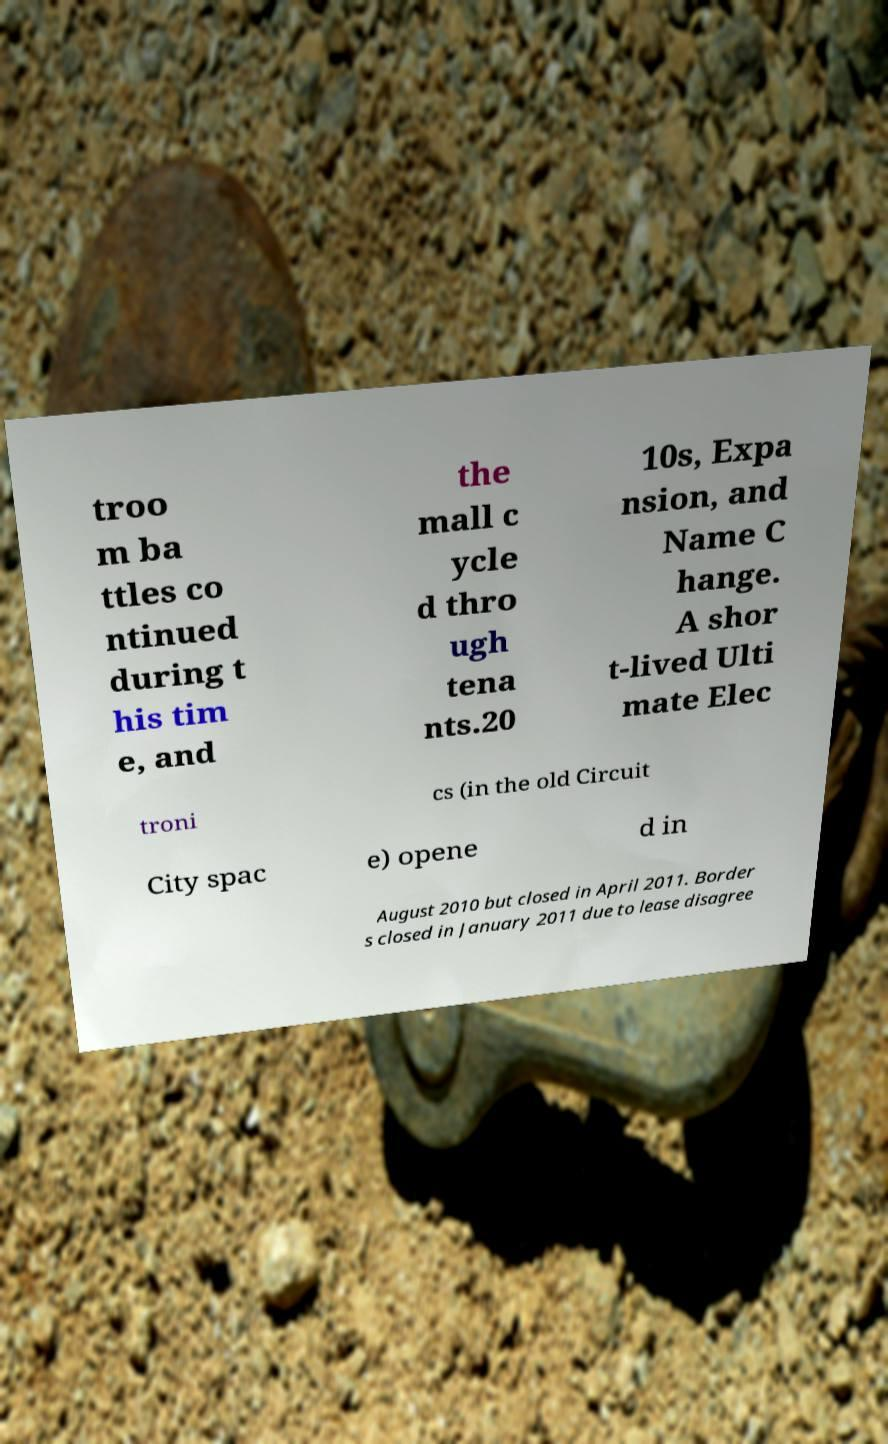Please read and relay the text visible in this image. What does it say? troo m ba ttles co ntinued during t his tim e, and the mall c ycle d thro ugh tena nts.20 10s, Expa nsion, and Name C hange. A shor t-lived Ulti mate Elec troni cs (in the old Circuit City spac e) opene d in August 2010 but closed in April 2011. Border s closed in January 2011 due to lease disagree 